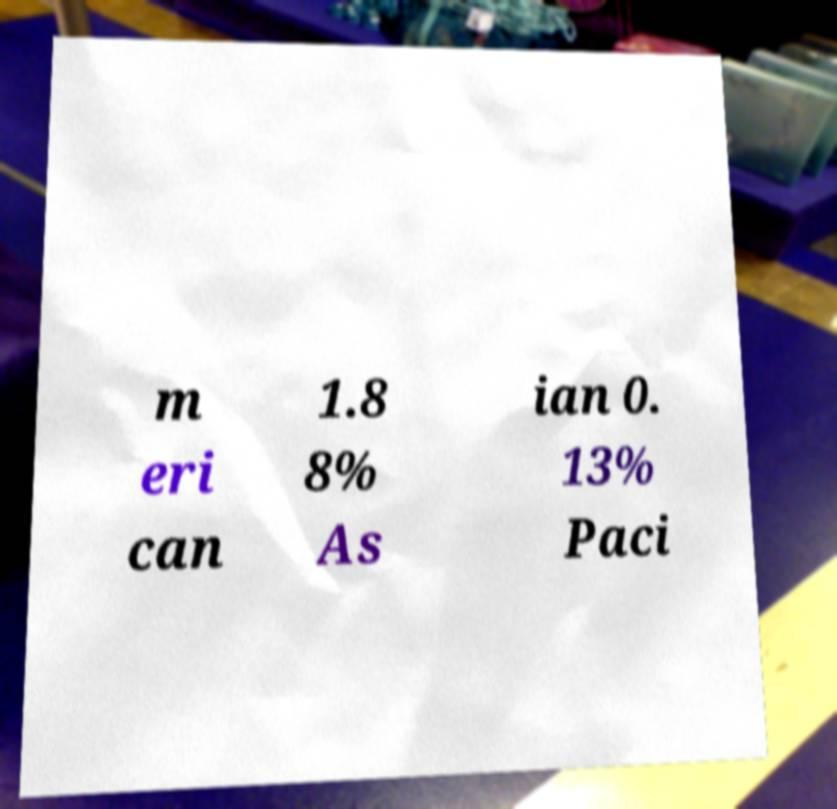Could you extract and type out the text from this image? m eri can 1.8 8% As ian 0. 13% Paci 